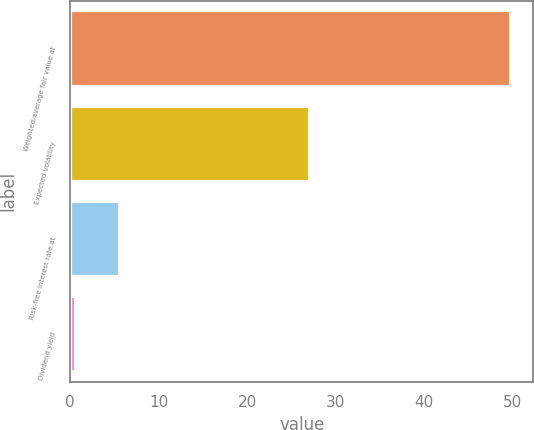<chart> <loc_0><loc_0><loc_500><loc_500><bar_chart><fcel>Weighted-average fair value at<fcel>Expected volatility<fcel>Risk-free interest rate at<fcel>Dividend yield<nl><fcel>49.81<fcel>27.1<fcel>5.61<fcel>0.7<nl></chart> 